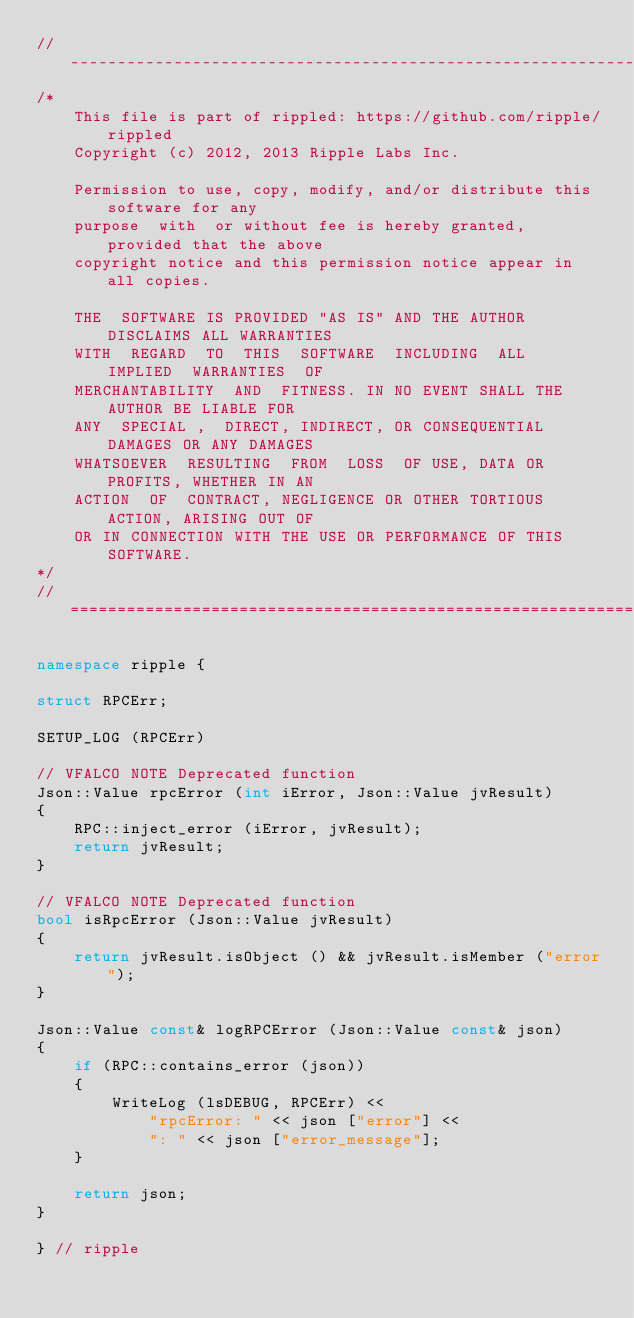Convert code to text. <code><loc_0><loc_0><loc_500><loc_500><_C++_>//------------------------------------------------------------------------------
/*
    This file is part of rippled: https://github.com/ripple/rippled
    Copyright (c) 2012, 2013 Ripple Labs Inc.

    Permission to use, copy, modify, and/or distribute this software for any
    purpose  with  or without fee is hereby granted, provided that the above
    copyright notice and this permission notice appear in all copies.

    THE  SOFTWARE IS PROVIDED "AS IS" AND THE AUTHOR DISCLAIMS ALL WARRANTIES
    WITH  REGARD  TO  THIS  SOFTWARE  INCLUDING  ALL  IMPLIED  WARRANTIES  OF
    MERCHANTABILITY  AND  FITNESS. IN NO EVENT SHALL THE AUTHOR BE LIABLE FOR
    ANY  SPECIAL ,  DIRECT, INDIRECT, OR CONSEQUENTIAL DAMAGES OR ANY DAMAGES
    WHATSOEVER  RESULTING  FROM  LOSS  OF USE, DATA OR PROFITS, WHETHER IN AN
    ACTION  OF  CONTRACT, NEGLIGENCE OR OTHER TORTIOUS ACTION, ARISING OUT OF
    OR IN CONNECTION WITH THE USE OR PERFORMANCE OF THIS SOFTWARE.
*/
//==============================================================================

namespace ripple {

struct RPCErr;

SETUP_LOG (RPCErr)

// VFALCO NOTE Deprecated function
Json::Value rpcError (int iError, Json::Value jvResult)
{
    RPC::inject_error (iError, jvResult);
    return jvResult;
}

// VFALCO NOTE Deprecated function
bool isRpcError (Json::Value jvResult)
{
    return jvResult.isObject () && jvResult.isMember ("error");
}

Json::Value const& logRPCError (Json::Value const& json)
{
    if (RPC::contains_error (json))
    {
        WriteLog (lsDEBUG, RPCErr) <<
            "rpcError: " << json ["error"] <<
            ": " << json ["error_message"];
    }

    return json;
}

} // ripple

</code> 